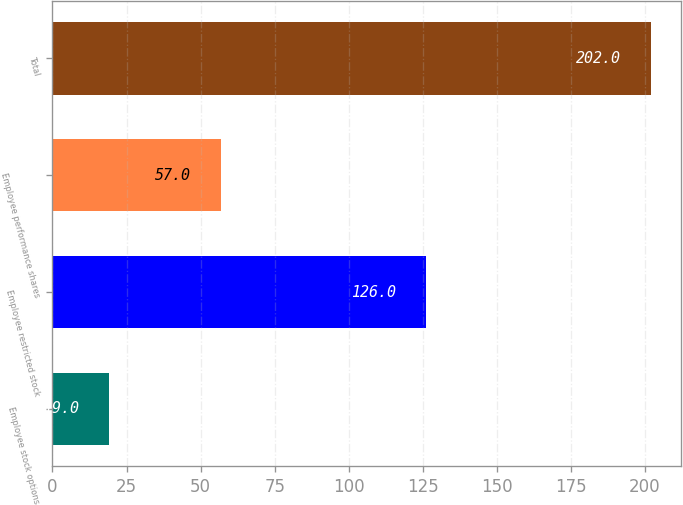Convert chart to OTSL. <chart><loc_0><loc_0><loc_500><loc_500><bar_chart><fcel>Employee stock options<fcel>Employee restricted stock<fcel>Employee performance shares<fcel>Total<nl><fcel>19<fcel>126<fcel>57<fcel>202<nl></chart> 